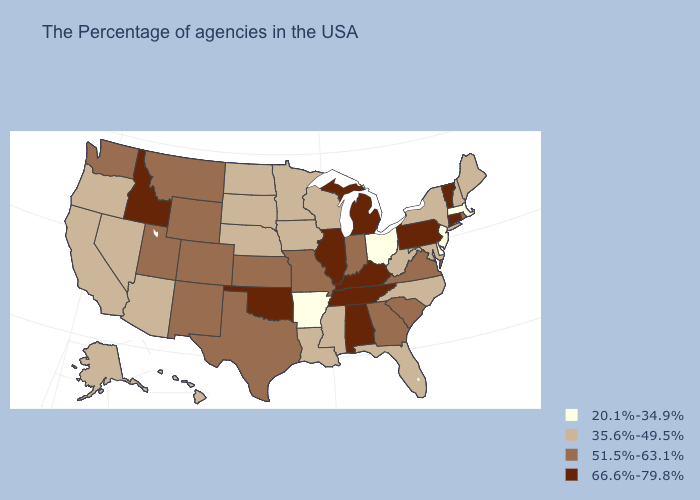Name the states that have a value in the range 35.6%-49.5%?
Quick response, please. Maine, New Hampshire, New York, Maryland, North Carolina, West Virginia, Florida, Wisconsin, Mississippi, Louisiana, Minnesota, Iowa, Nebraska, South Dakota, North Dakota, Arizona, Nevada, California, Oregon, Alaska, Hawaii. What is the value of North Carolina?
Write a very short answer. 35.6%-49.5%. Does Connecticut have the lowest value in the Northeast?
Write a very short answer. No. Name the states that have a value in the range 66.6%-79.8%?
Be succinct. Vermont, Connecticut, Pennsylvania, Michigan, Kentucky, Alabama, Tennessee, Illinois, Oklahoma, Idaho. What is the lowest value in the MidWest?
Keep it brief. 20.1%-34.9%. Does the map have missing data?
Be succinct. No. Among the states that border Idaho , which have the highest value?
Answer briefly. Wyoming, Utah, Montana, Washington. What is the highest value in states that border Maryland?
Give a very brief answer. 66.6%-79.8%. Does Utah have a higher value than Alaska?
Answer briefly. Yes. Among the states that border Virginia , which have the lowest value?
Concise answer only. Maryland, North Carolina, West Virginia. Name the states that have a value in the range 20.1%-34.9%?
Short answer required. Massachusetts, New Jersey, Delaware, Ohio, Arkansas. Name the states that have a value in the range 35.6%-49.5%?
Short answer required. Maine, New Hampshire, New York, Maryland, North Carolina, West Virginia, Florida, Wisconsin, Mississippi, Louisiana, Minnesota, Iowa, Nebraska, South Dakota, North Dakota, Arizona, Nevada, California, Oregon, Alaska, Hawaii. Does Wisconsin have the lowest value in the USA?
Be succinct. No. Name the states that have a value in the range 51.5%-63.1%?
Short answer required. Rhode Island, Virginia, South Carolina, Georgia, Indiana, Missouri, Kansas, Texas, Wyoming, Colorado, New Mexico, Utah, Montana, Washington. Does Ohio have the lowest value in the USA?
Concise answer only. Yes. 